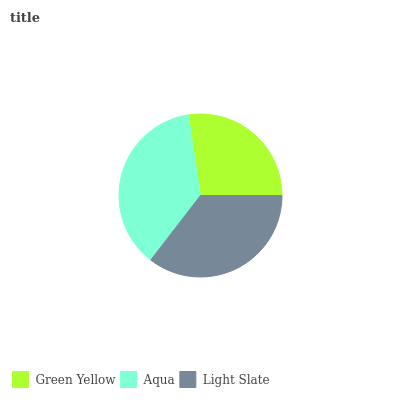Is Green Yellow the minimum?
Answer yes or no. Yes. Is Aqua the maximum?
Answer yes or no. Yes. Is Light Slate the minimum?
Answer yes or no. No. Is Light Slate the maximum?
Answer yes or no. No. Is Aqua greater than Light Slate?
Answer yes or no. Yes. Is Light Slate less than Aqua?
Answer yes or no. Yes. Is Light Slate greater than Aqua?
Answer yes or no. No. Is Aqua less than Light Slate?
Answer yes or no. No. Is Light Slate the high median?
Answer yes or no. Yes. Is Light Slate the low median?
Answer yes or no. Yes. Is Aqua the high median?
Answer yes or no. No. Is Green Yellow the low median?
Answer yes or no. No. 